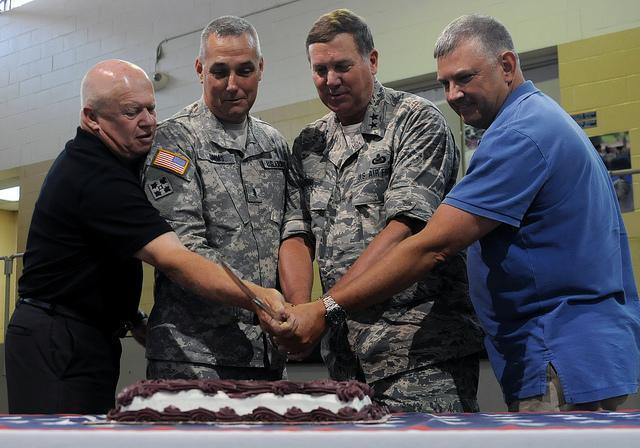How many men?
Give a very brief answer. 4. How many candles are there?
Give a very brief answer. 0. How many people can you see?
Give a very brief answer. 4. 